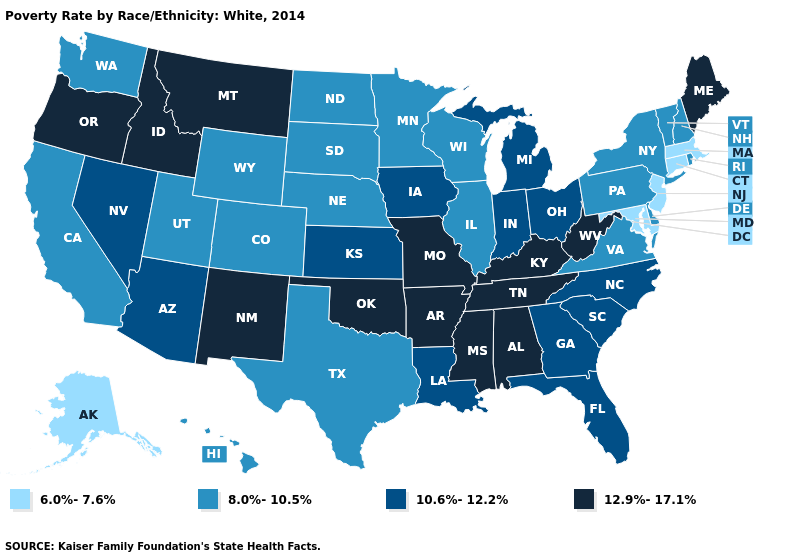What is the highest value in the South ?
Keep it brief. 12.9%-17.1%. What is the lowest value in the USA?
Concise answer only. 6.0%-7.6%. Name the states that have a value in the range 12.9%-17.1%?
Answer briefly. Alabama, Arkansas, Idaho, Kentucky, Maine, Mississippi, Missouri, Montana, New Mexico, Oklahoma, Oregon, Tennessee, West Virginia. Which states hav the highest value in the Northeast?
Short answer required. Maine. What is the lowest value in states that border Nebraska?
Keep it brief. 8.0%-10.5%. Name the states that have a value in the range 10.6%-12.2%?
Keep it brief. Arizona, Florida, Georgia, Indiana, Iowa, Kansas, Louisiana, Michigan, Nevada, North Carolina, Ohio, South Carolina. What is the value of Arizona?
Answer briefly. 10.6%-12.2%. What is the highest value in states that border Indiana?
Answer briefly. 12.9%-17.1%. Name the states that have a value in the range 12.9%-17.1%?
Short answer required. Alabama, Arkansas, Idaho, Kentucky, Maine, Mississippi, Missouri, Montana, New Mexico, Oklahoma, Oregon, Tennessee, West Virginia. What is the value of Vermont?
Concise answer only. 8.0%-10.5%. Does Idaho have a higher value than Kentucky?
Concise answer only. No. What is the value of Utah?
Short answer required. 8.0%-10.5%. Name the states that have a value in the range 6.0%-7.6%?
Be succinct. Alaska, Connecticut, Maryland, Massachusetts, New Jersey. What is the value of Michigan?
Keep it brief. 10.6%-12.2%. Among the states that border Nebraska , does Kansas have the highest value?
Answer briefly. No. 